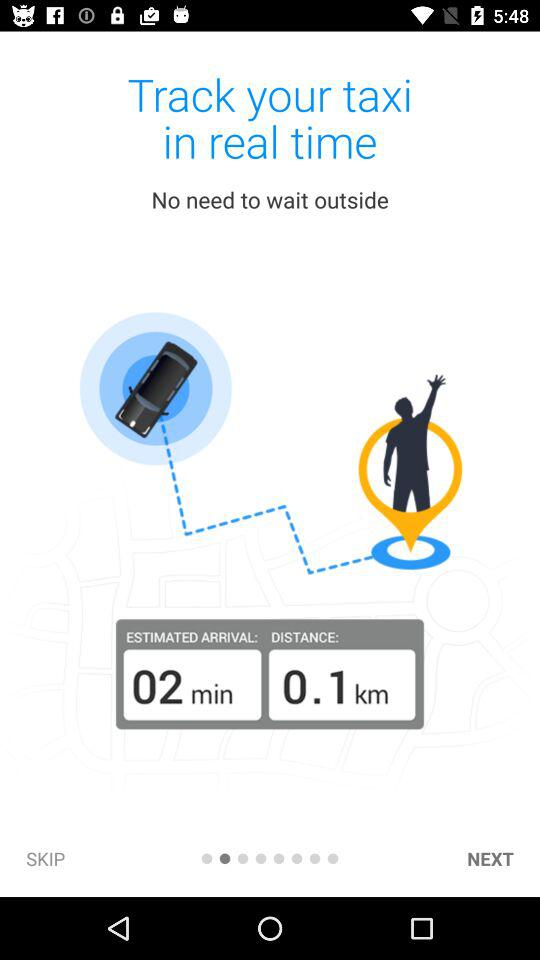What is the estimated time of arrival? The estimated time of arrival is 2 minutes. 